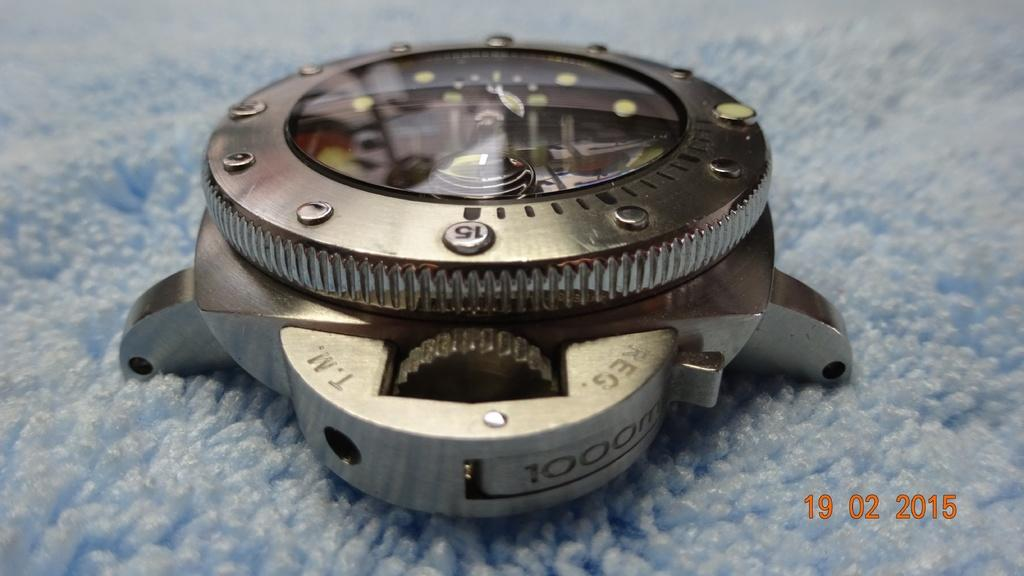Provide a one-sentence caption for the provided image. a technical looking instrument with a date of 19 02 2015 on the bottom right. 